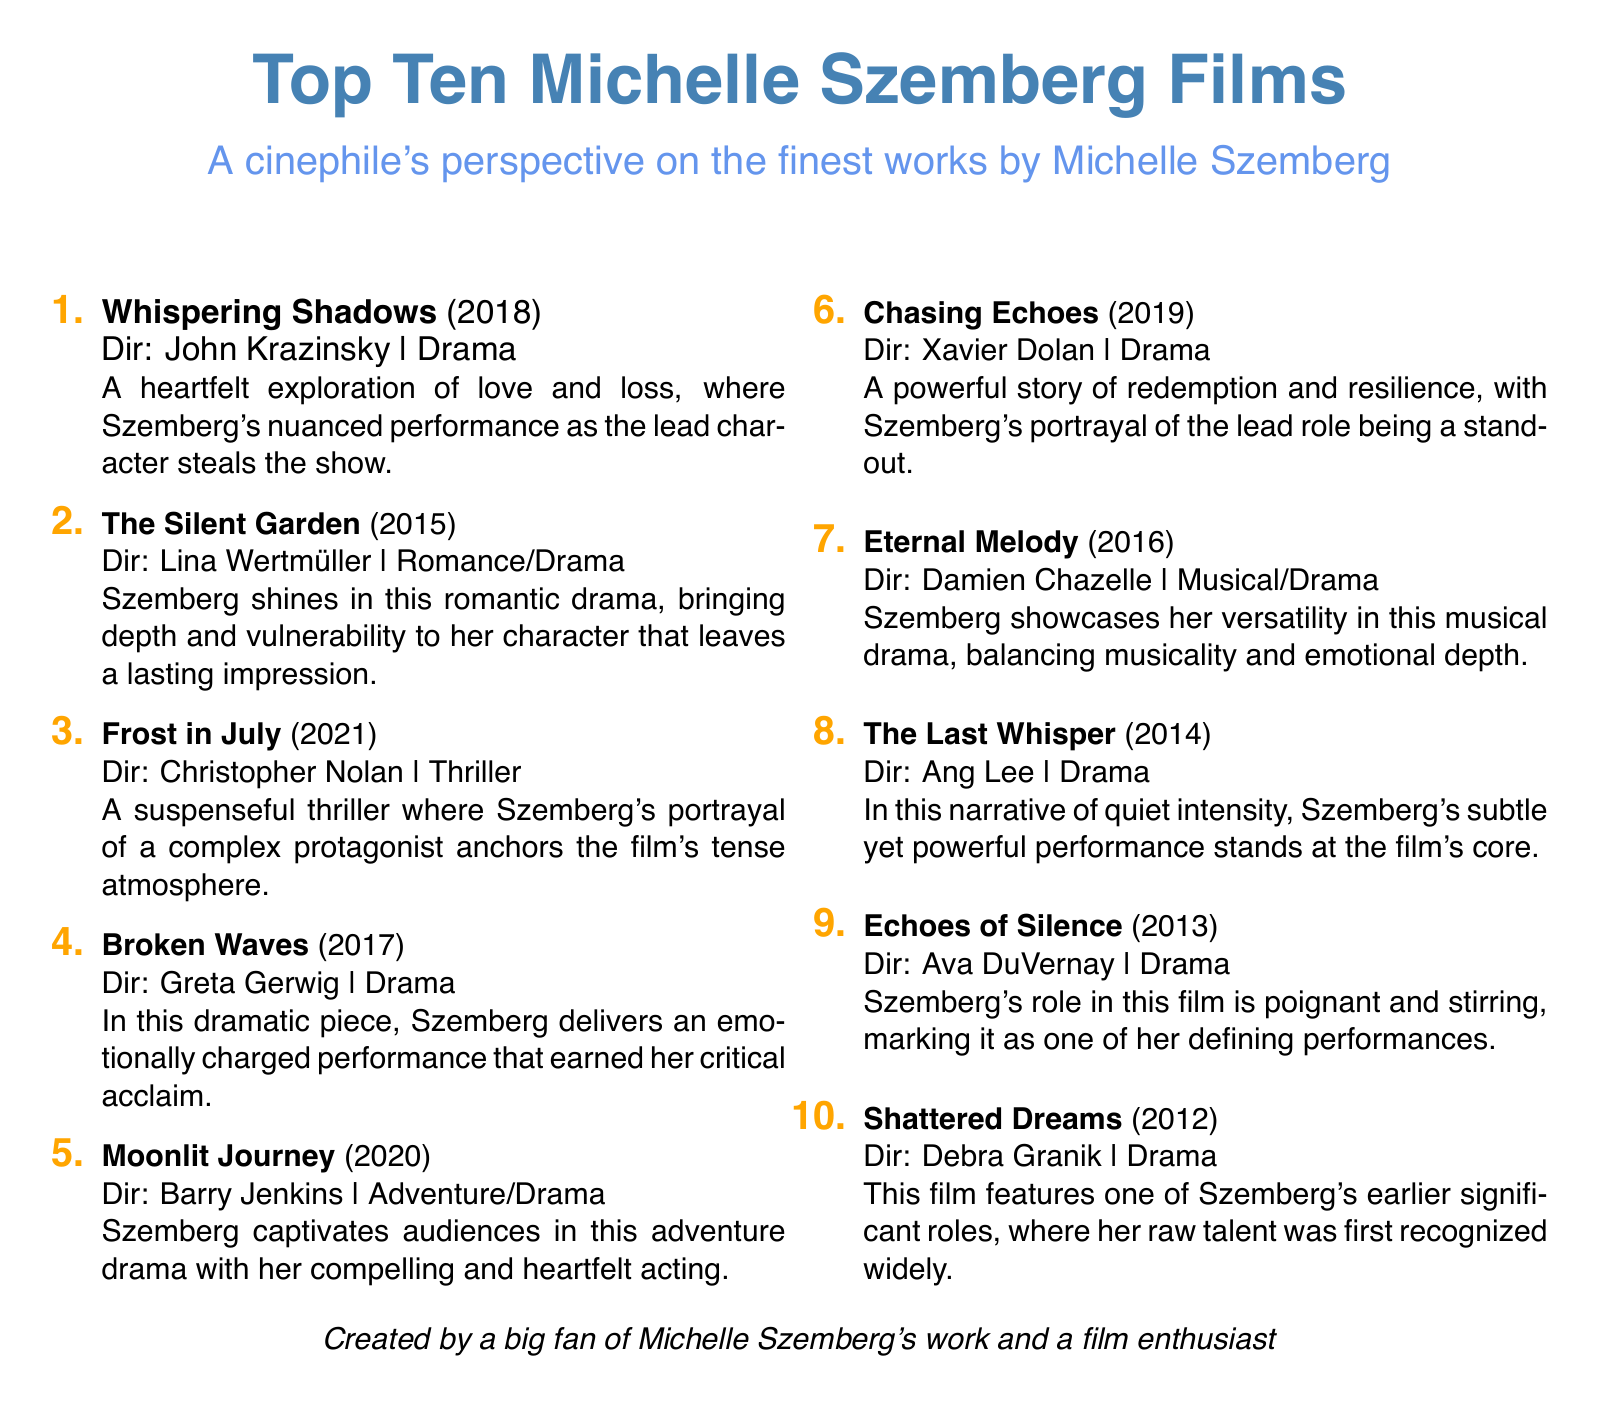What is the title of Michelle Szemberg's film released in 2018? The document lists "Whispering Shadows" as the film released in 2018.
Answer: Whispering Shadows Who directed "The Silent Garden"? The director of "The Silent Garden" is Lina Wertmüller as mentioned in the document.
Answer: Lina Wertmüller What genre is "Frost in July"? The genre of "Frost in July" is Thriller as specified in the document.
Answer: Thriller Which film features a musical element in its genre? "Eternal Melody" is noted as a Musical/Drama in the document.
Answer: Eternal Melody What year was "Chasing Echoes" released? "Chasing Echoes" was released in 2019 according to the document.
Answer: 2019 How many films are listed in the document? The total number of films listed is ten, as the title indicates Top Ten Michelle Szemberg Films.
Answer: Ten Who directed the film "Broken Waves"? The director of "Broken Waves" is Greta Gerwig, as noted in the document.
Answer: Greta Gerwig What is a common theme found in Michelle Szemberg's films according to the descriptions? The descriptions suggest themes of love, loss, and emotional depth are common in her films.
Answer: Love and loss 